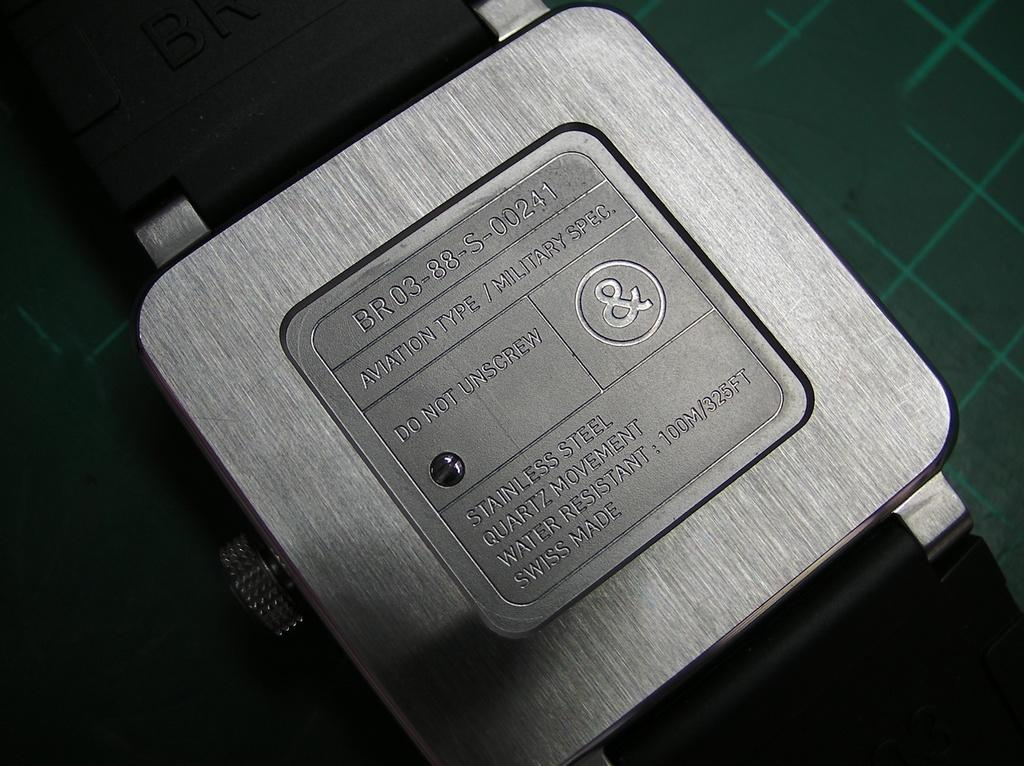<image>
Provide a brief description of the given image. back of a stainless steel watch with a warning not to unscrew the screw 